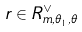<formula> <loc_0><loc_0><loc_500><loc_500>r \in R _ { m , \theta _ { 1 } , \theta } ^ { \vee }</formula> 